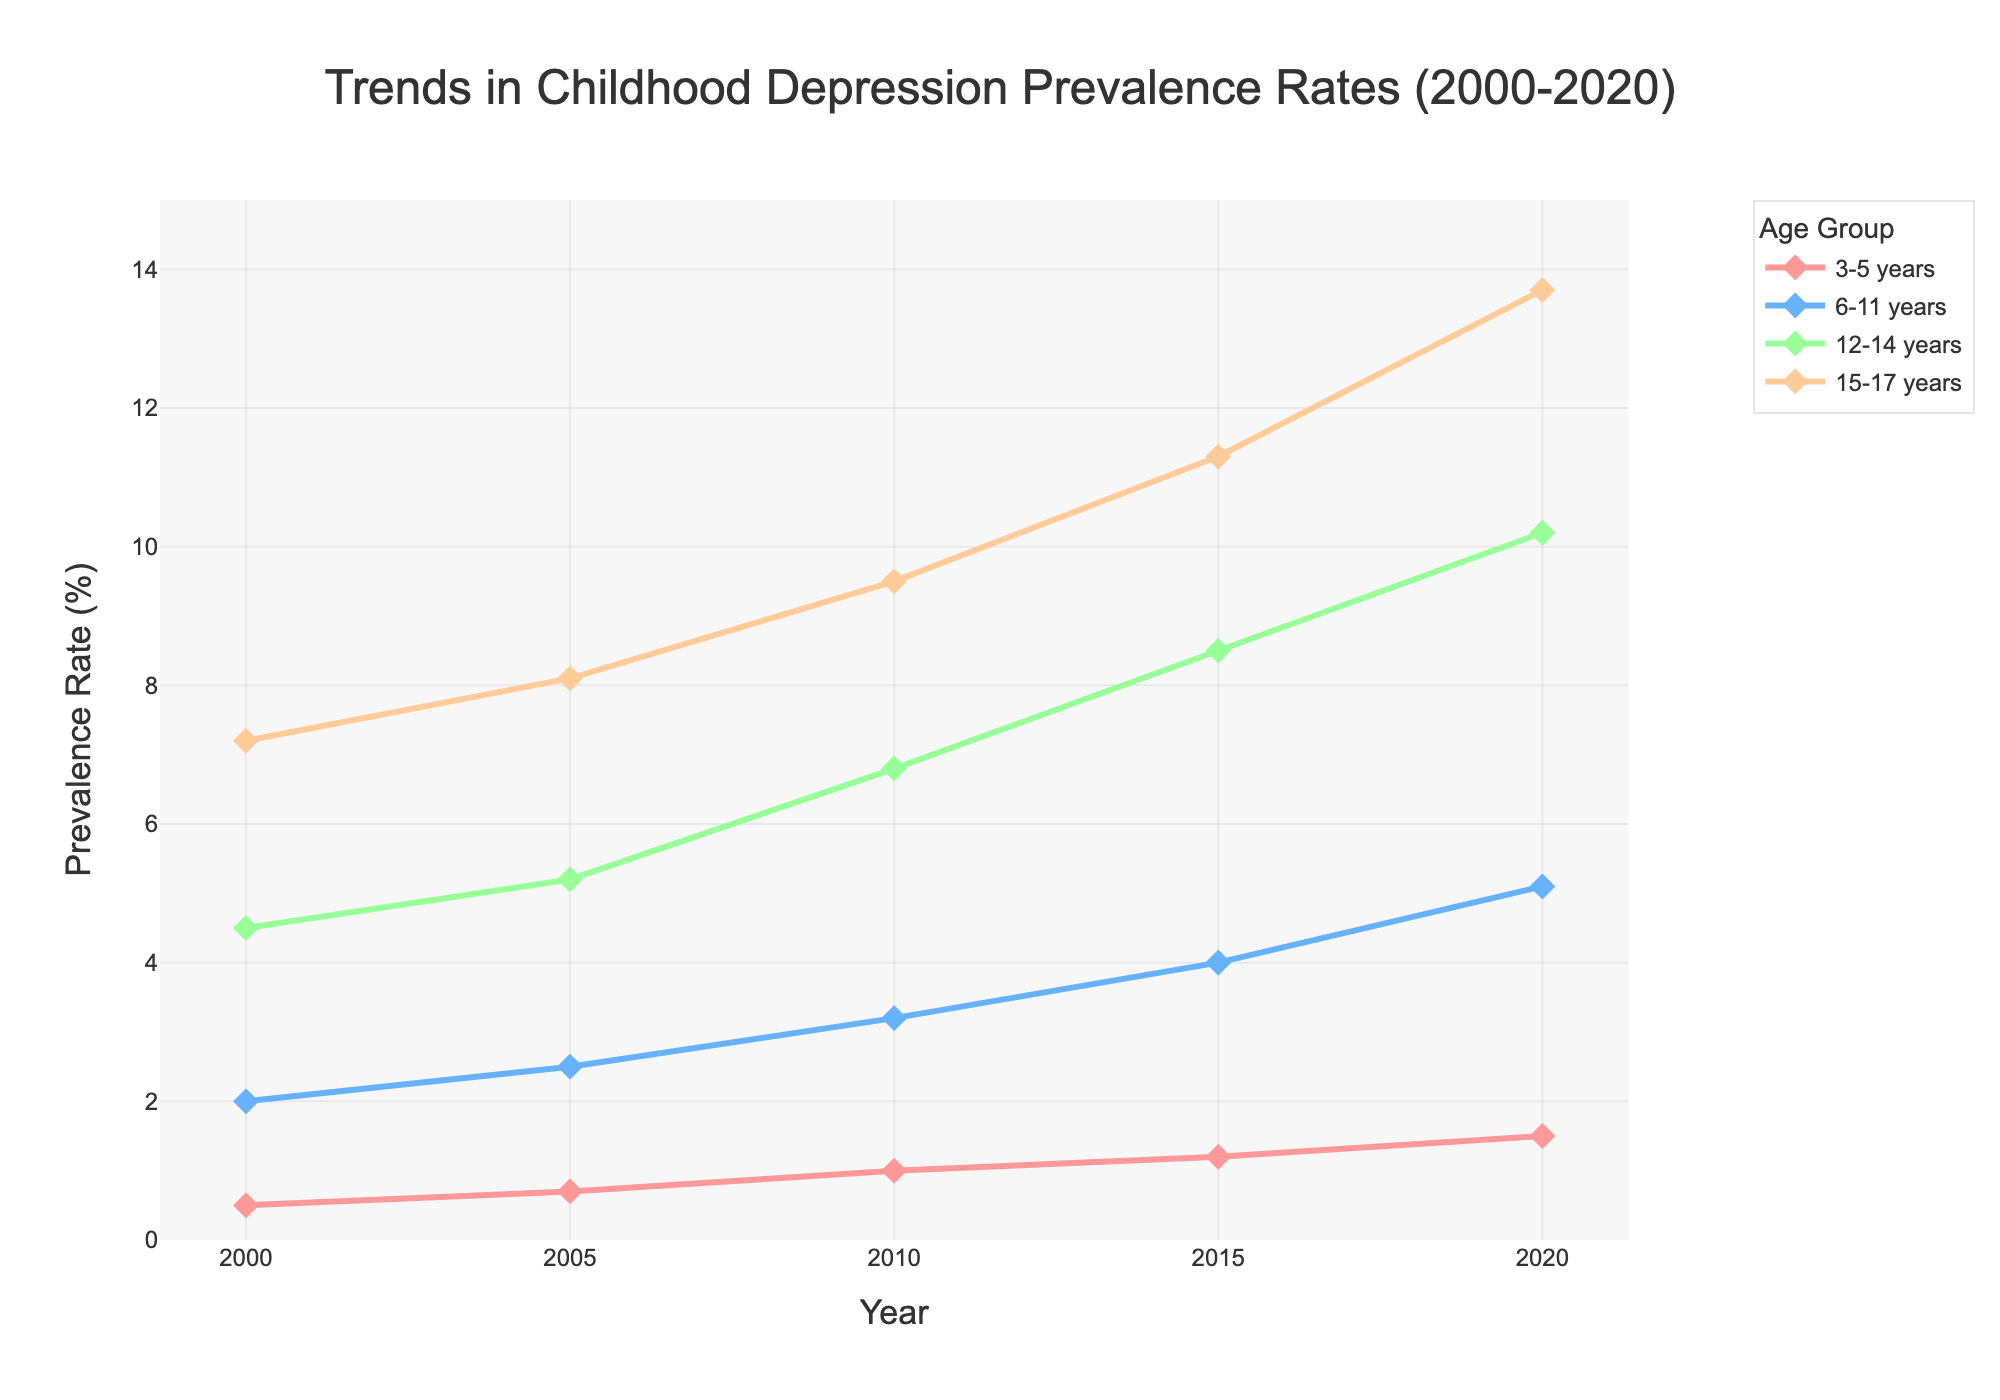what is the prevalence rate for 3-5 years in 2020? Locate the line corresponding to the 3-5 years age group, then find the value where this line intersects the 2020 x-axis. The prevalence rate for 3-5 years in 2020 is 1.5%.
Answer: 1.5% which age group had the highest prevalence rate in 2010? Review the y-values for all age groups at the 2010 x-axis point. The 15-17 years age group has the highest prevalence rate in 2010, which is 9.5%.
Answer: 15-17 years what is the difference in prevalence rates between the 6-11 years and 12-14 years age groups in 2020? Locate the prevalence rates for both age groups in 2020. The rate for 6-11 years is 5.1%, and for 12-14 years is 10.2%. The difference is 10.2% - 5.1% = 5.1%.
Answer: 5.1% what is the average increase in prevalence rate per decade for the 15-17 years age group from 2000 to 2020? Calculate the increase in prevalence rate between each decade for the 15-17 years age group. From 2000 to 2020, the increases are: 8.1 - 7.2 = 0.9, 9.5 - 8.1 = 1.4, 11.3 - 9.5 = 1.8, 13.7 - 11.3 = 2.4. The average increase per decade is (0.9 + 1.4 + 1.8 + 2.4)/4 = 1.625%.
Answer: 1.625% which age group showed the fastest increase in prevalence rate from 2005 to 2010? Compare the slopes of the lines for all age groups between 2005 and 2010. The fastest increase is for the 12-14 years age group, rising from 5.2% to 6.8%, an increase of 1.6%.
Answer: 12-14 years what is the total increase in prevalence rate for the 6-11 years age group from 2000 to 2020? Locate the prevalence rate for the 6-11 years age group in 2000 and 2020. The increase is 5.1% (2020) - 2.0% (2000) = 3.1%.
Answer: 3.1% how does the trend of prevalence rates for the 3-5 years age group compare to the 15-17 years age group from 2000 to 2020? Observe the slope and pattern of the lines for each age group. The 3-5 years age group shows a gradual and consistent increase, while the 15-17 years age group has a steeper and more pronounced increase over the same period.
Answer: 3-5 years shows a gradual increase, 15-17 years shows a steep increase which age group had the least change in prevalence rate from 2000 to 2005? Evaluate the change in prevalence rate for each age group between 2000 and 2005. The 3-5 years age group has the smallest change, increasing from 0.5% to 0.7%, a change of 0.2%.
Answer: 3-5 years 